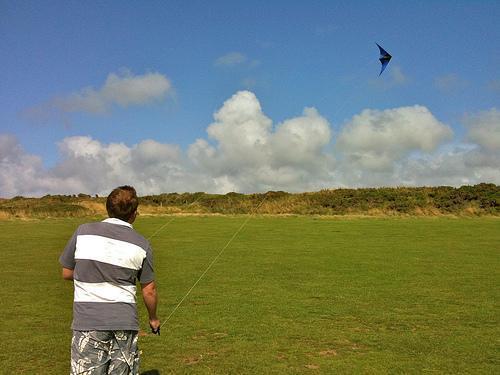How many kites are in the photo?
Give a very brief answer. 1. 